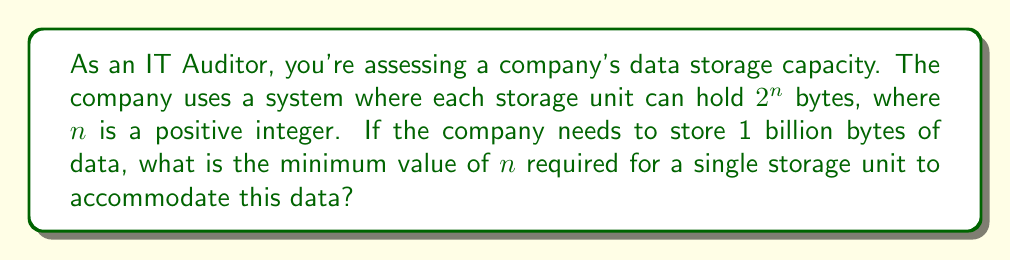Could you help me with this problem? Let's approach this step-by-step:

1) We need to find $n$ such that $2^n \geq 1,000,000,000$ (1 billion bytes)

2) Taking the logarithm (base 2) of both sides:
   $$\log_2(2^n) \geq \log_2(1,000,000,000)$$

3) Using the logarithm property $\log_a(a^x) = x$:
   $$n \geq \log_2(1,000,000,000)$$

4) We can calculate $\log_2(1,000,000,000)$ using the change of base formula:
   $$\log_2(1,000,000,000) = \frac{\log(1,000,000,000)}{\log(2)}$$

5) Using a calculator or computer:
   $$\frac{\log(1,000,000,000)}{\log(2)} \approx 29.8974$$

6) Since $n$ must be a positive integer, we need to round up to the next whole number:
   $$n = \lceil 29.8974 \rceil = 30$$

Therefore, the minimum value of $n$ required is 30.
Answer: 30 